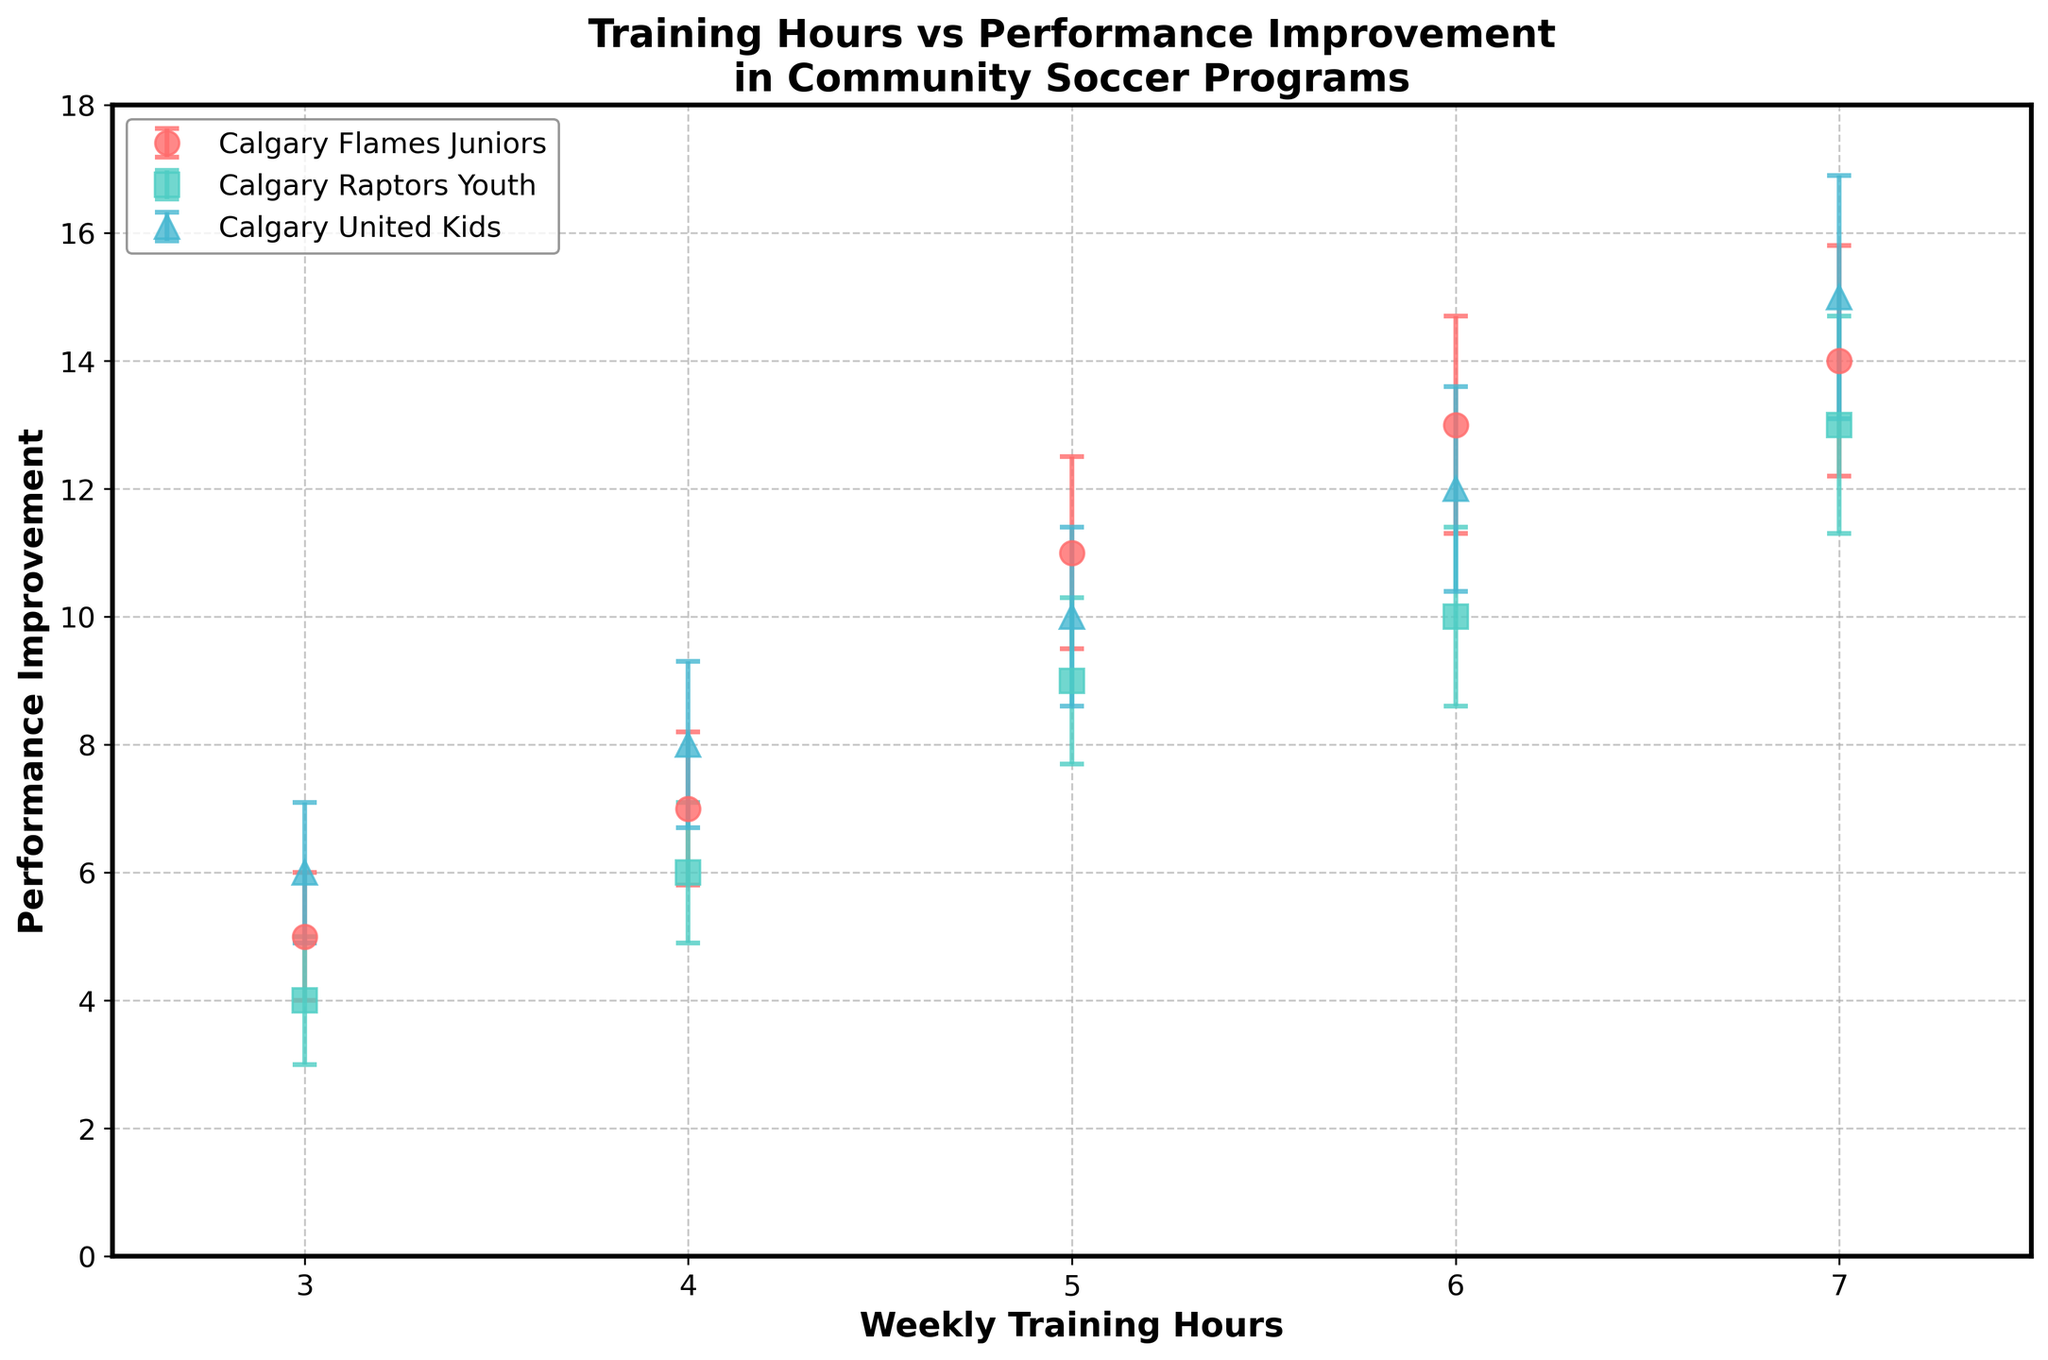What is the title of the plot? The title of the plot is usually located at the top. It reads, "Training Hours vs Performance Improvement in Community Soccer Programs."
Answer: Training Hours vs Performance Improvement in Community Soccer Programs How many teams are represented in the plot? By examining the legend and the distinct markers/colors, we can see there are three teams: Calgary Flames Juniors, Calgary Raptors Youth, and Calgary United Kids.
Answer: 3 What training hour values are shown on the x-axis for Calgary Raptors Youth? Looking at the markers for Calgary Raptors Youth in the plot, the x-axis values are 3, 4, 5, 6, and 7 training hours.
Answer: 3, 4, 5, 6, 7 Which team shows the highest performance improvement at 7 training hours? At the 7 training hours mark, the performance improvement values for all teams can be checked. Calgary United Kids reach a performance improvement of 15, which is the highest among the teams.
Answer: Calgary United Kids What is the performance improvement value range for Calgary Flames Juniors? The performance improvement values for Calgary Flames Juniors range from the lowest value of 5 to the highest value of 14, as indicated by the data points.
Answer: 5-14 What is the average performance improvement for Calgary Flames Juniors? The performance improvement values for Calgary Flames Juniors are 5, 7, 11, 13, and 14. Their sum is 50, and the average is found by dividing by the number of points: 50 / 5 = 10.
Answer: 10 Which team has the smallest error bar at 4 training hours? By examining the error bars at 4 training hours for all teams, Calgary Raptors Youth has the smallest error bar of 1.1.
Answer: Calgary Raptors Youth How does the performance improvement at 6 training hours compare between Calgary Flames Juniors and Calgary Raptors Youth? At 6 training hours, Calgary Flames Juniors show a performance improvement of 13, while Calgary Raptors Youth show 10. Thus, Calgary Flames Juniors have a higher improvement.
Answer: Calgary Flames Juniors higher What is the difference in performance improvement between Calgary United Kids and Calgary Flames Juniors at 5 training hours? At 5 training hours, Calgary United Kids' improvement is 10, while Calgary Flames Juniors' improvement is 11. The difference is
Answer: 1 